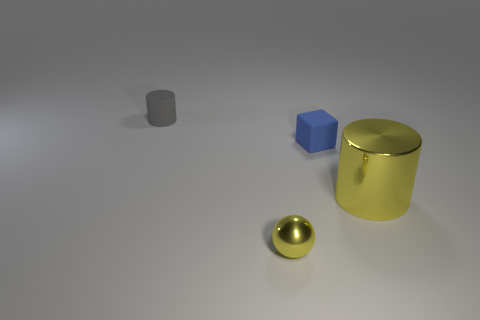Add 1 large yellow shiny cylinders. How many objects exist? 5 Subtract all gray cylinders. How many cylinders are left? 1 Subtract all green balls. Subtract all cyan cubes. How many balls are left? 1 Subtract all yellow blocks. How many gray cylinders are left? 1 Add 2 yellow metal cylinders. How many yellow metal cylinders exist? 3 Subtract 0 yellow blocks. How many objects are left? 4 Subtract all spheres. How many objects are left? 3 Subtract 2 cylinders. How many cylinders are left? 0 Subtract all small yellow metal things. Subtract all tiny yellow things. How many objects are left? 2 Add 3 matte cylinders. How many matte cylinders are left? 4 